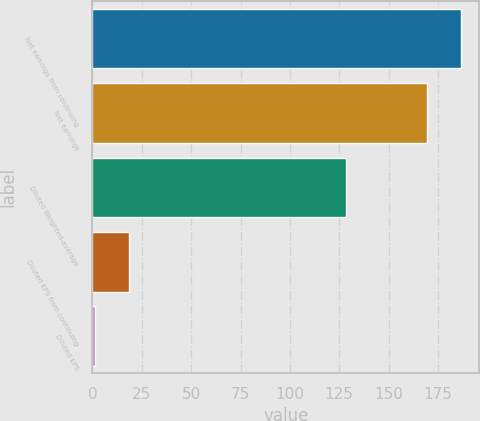Convert chart to OTSL. <chart><loc_0><loc_0><loc_500><loc_500><bar_chart><fcel>Net earnings from continuing<fcel>Net earnings<fcel>Diluted Weighted-average<fcel>Diluted EPS from continuing<fcel>Diluted EPS<nl><fcel>186.65<fcel>169.6<fcel>128.3<fcel>18.37<fcel>1.32<nl></chart> 